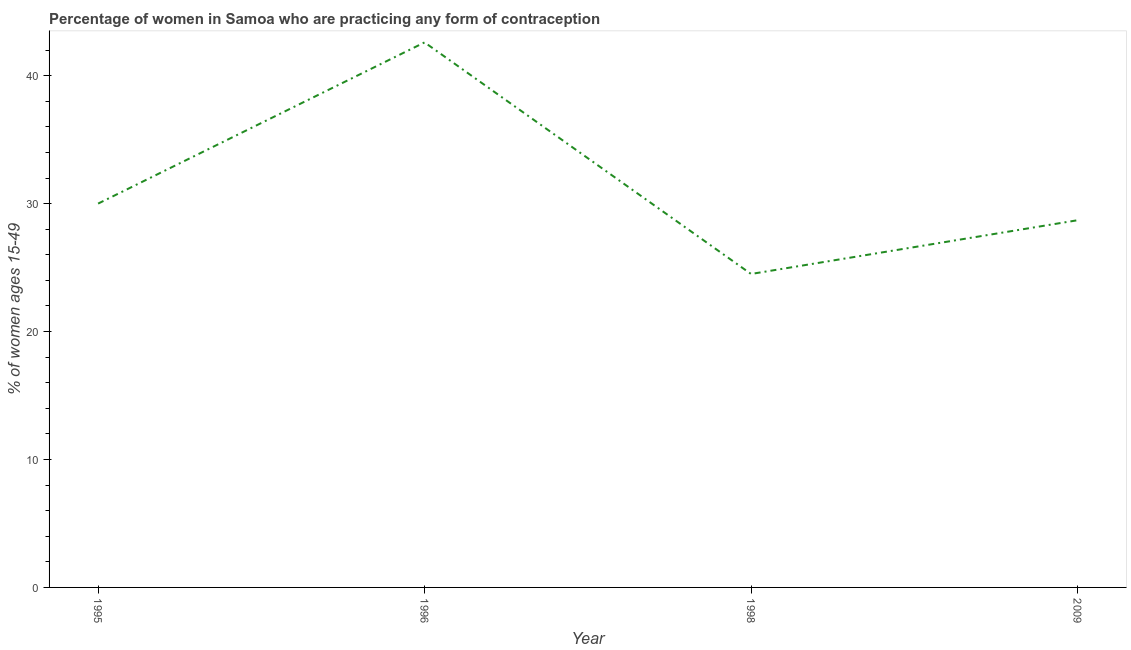What is the contraceptive prevalence in 2009?
Your answer should be compact. 28.7. Across all years, what is the maximum contraceptive prevalence?
Make the answer very short. 42.6. What is the sum of the contraceptive prevalence?
Your response must be concise. 125.8. What is the average contraceptive prevalence per year?
Your answer should be compact. 31.45. What is the median contraceptive prevalence?
Provide a short and direct response. 29.35. In how many years, is the contraceptive prevalence greater than 16 %?
Keep it short and to the point. 4. Do a majority of the years between 1998 and 2009 (inclusive) have contraceptive prevalence greater than 14 %?
Give a very brief answer. Yes. What is the ratio of the contraceptive prevalence in 1996 to that in 2009?
Ensure brevity in your answer.  1.48. What is the difference between the highest and the second highest contraceptive prevalence?
Ensure brevity in your answer.  12.6. Is the sum of the contraceptive prevalence in 1995 and 1996 greater than the maximum contraceptive prevalence across all years?
Your answer should be very brief. Yes. What is the difference between the highest and the lowest contraceptive prevalence?
Provide a short and direct response. 18.1. Does the contraceptive prevalence monotonically increase over the years?
Offer a terse response. No. How many lines are there?
Offer a terse response. 1. Are the values on the major ticks of Y-axis written in scientific E-notation?
Offer a very short reply. No. Does the graph contain any zero values?
Ensure brevity in your answer.  No. Does the graph contain grids?
Ensure brevity in your answer.  No. What is the title of the graph?
Provide a short and direct response. Percentage of women in Samoa who are practicing any form of contraception. What is the label or title of the Y-axis?
Offer a terse response. % of women ages 15-49. What is the % of women ages 15-49 of 1995?
Your answer should be very brief. 30. What is the % of women ages 15-49 in 1996?
Ensure brevity in your answer.  42.6. What is the % of women ages 15-49 of 1998?
Offer a very short reply. 24.5. What is the % of women ages 15-49 in 2009?
Your answer should be compact. 28.7. What is the difference between the % of women ages 15-49 in 1995 and 1996?
Offer a terse response. -12.6. What is the difference between the % of women ages 15-49 in 1996 and 1998?
Offer a very short reply. 18.1. What is the difference between the % of women ages 15-49 in 1996 and 2009?
Provide a short and direct response. 13.9. What is the ratio of the % of women ages 15-49 in 1995 to that in 1996?
Make the answer very short. 0.7. What is the ratio of the % of women ages 15-49 in 1995 to that in 1998?
Your answer should be very brief. 1.22. What is the ratio of the % of women ages 15-49 in 1995 to that in 2009?
Ensure brevity in your answer.  1.04. What is the ratio of the % of women ages 15-49 in 1996 to that in 1998?
Your answer should be compact. 1.74. What is the ratio of the % of women ages 15-49 in 1996 to that in 2009?
Give a very brief answer. 1.48. What is the ratio of the % of women ages 15-49 in 1998 to that in 2009?
Ensure brevity in your answer.  0.85. 